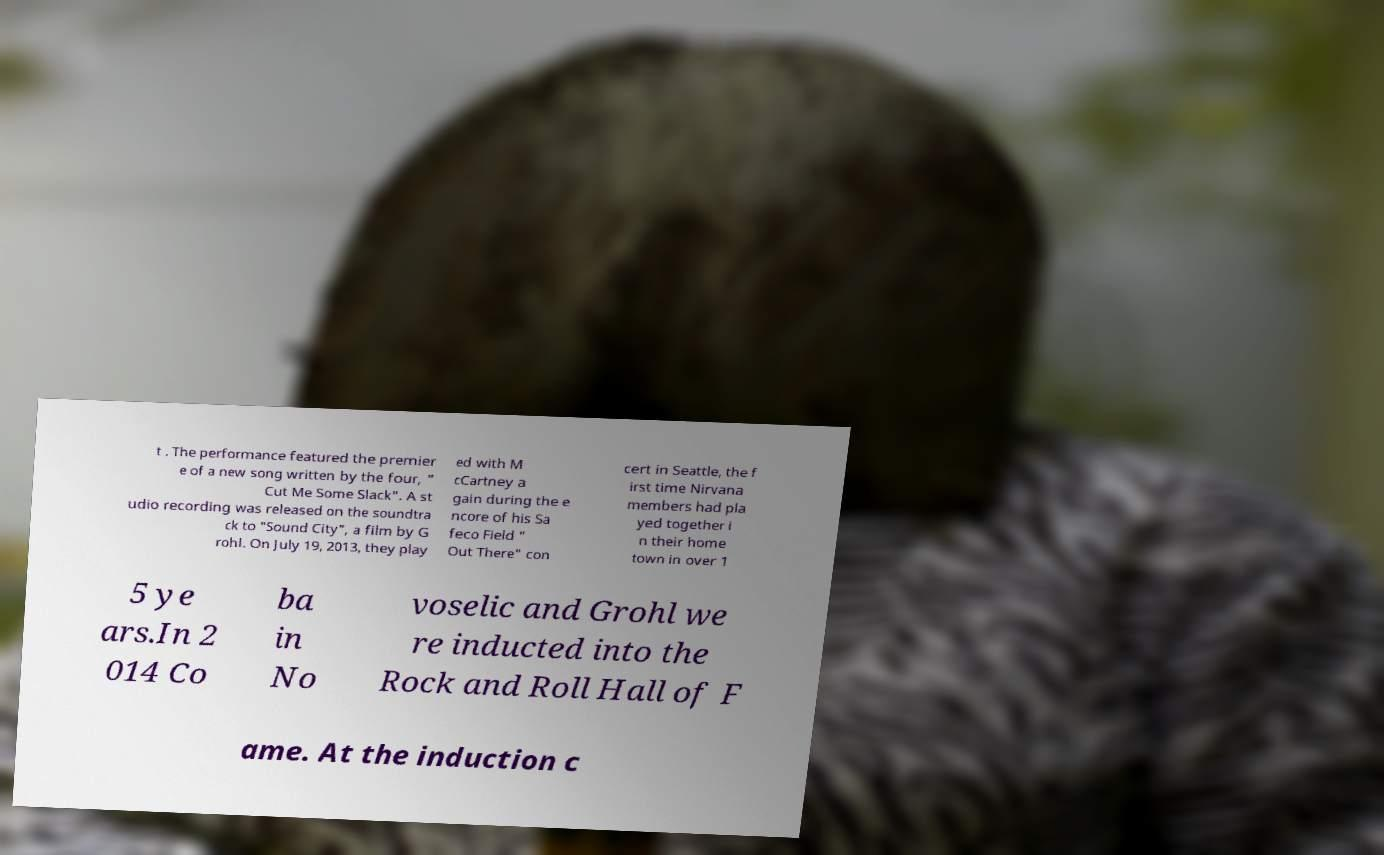Please read and relay the text visible in this image. What does it say? t . The performance featured the premier e of a new song written by the four, " Cut Me Some Slack". A st udio recording was released on the soundtra ck to "Sound City", a film by G rohl. On July 19, 2013, they play ed with M cCartney a gain during the e ncore of his Sa feco Field " Out There" con cert in Seattle, the f irst time Nirvana members had pla yed together i n their home town in over 1 5 ye ars.In 2 014 Co ba in No voselic and Grohl we re inducted into the Rock and Roll Hall of F ame. At the induction c 